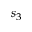<formula> <loc_0><loc_0><loc_500><loc_500>s _ { 3 }</formula> 